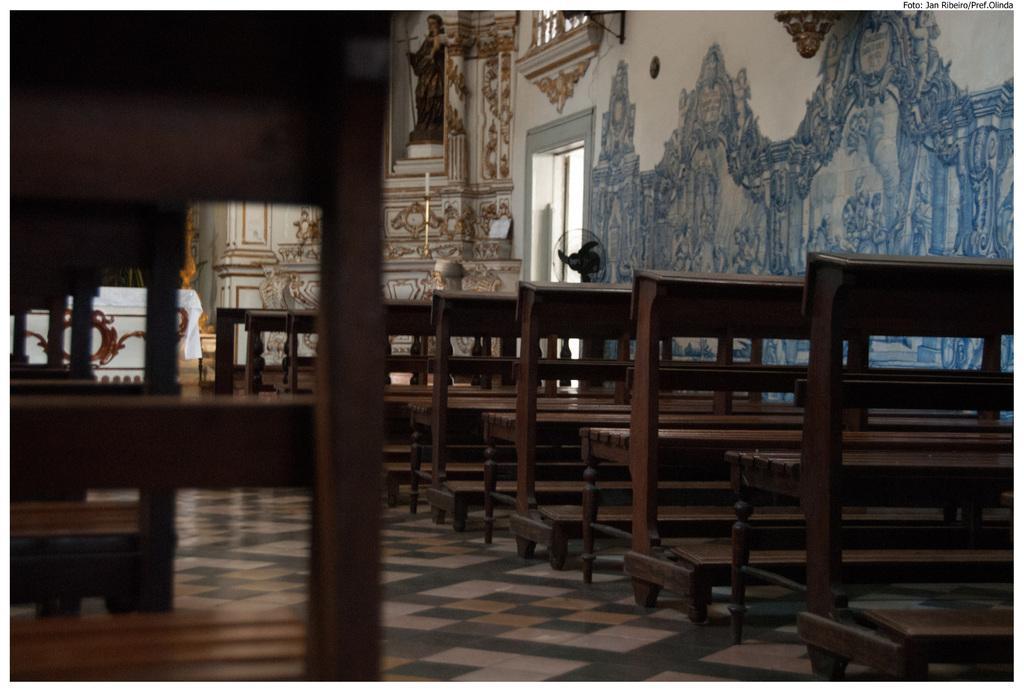Can you describe this image briefly? In the image in the center, we can see benches. In the background there is a statue and some art work on the wall. 